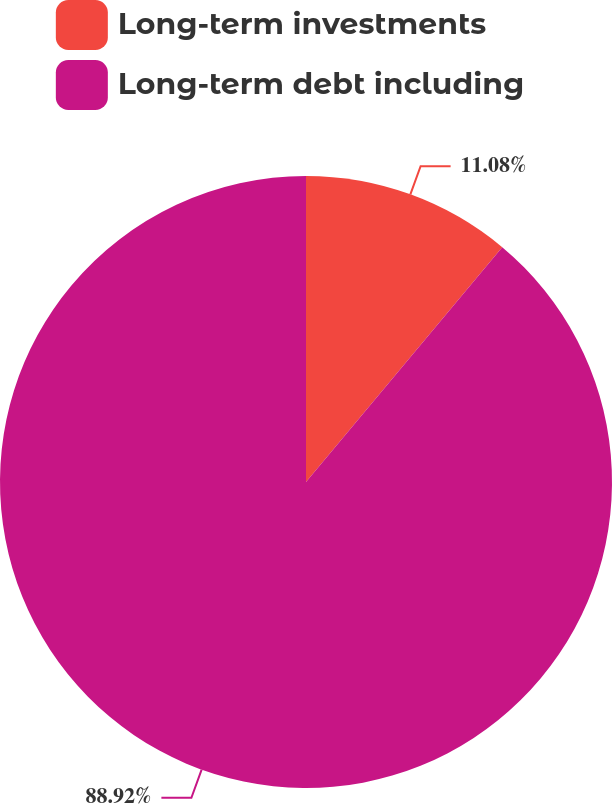Convert chart. <chart><loc_0><loc_0><loc_500><loc_500><pie_chart><fcel>Long-term investments<fcel>Long-term debt including<nl><fcel>11.08%<fcel>88.92%<nl></chart> 